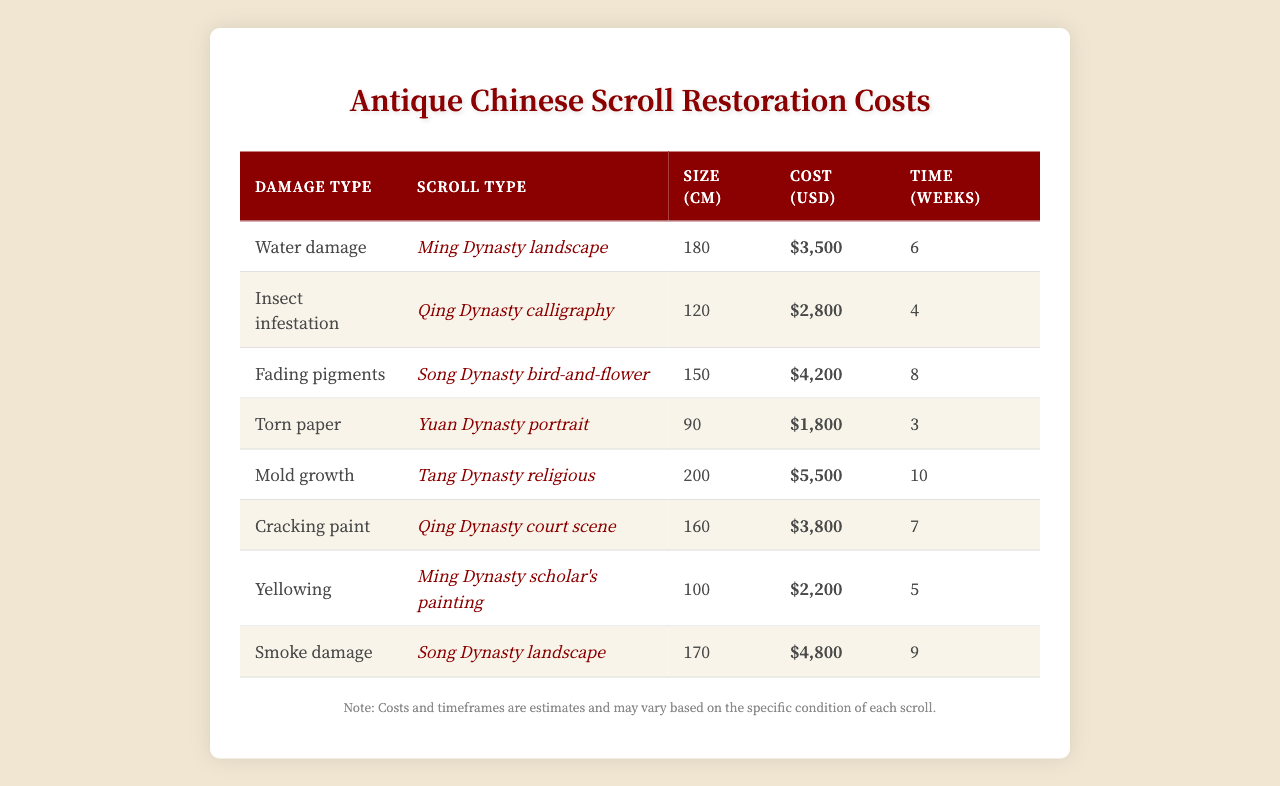What is the restoration cost for a "Ming Dynasty landscape" with water damage? The table indicates that the restoration cost for the "Ming Dynasty landscape" affected by water damage is $3,500.
Answer: $3,500 Which type of damage requires the longest restoration time? By examining the table, the type of damage that takes the longest, at 10 weeks, is mold growth associated with the "Tang Dynasty religious" scroll.
Answer: Mold growth What is the average restoration cost of the scrolls listed in the table? To find the average, first sum the costs: $3,500 + $2,800 + $4,200 + $1,800 + $5,500 + $3,800 + $2,200 + $4,800 = $24,600. Then, divide by the number of scrolls (8): $24,600 / 8 = $3,075.
Answer: $3,075 Which scroll type associated with fading pigments is the most costly to restore? The scroll type with fading pigments is the "Song Dynasty bird-and-flower," which has a restoration cost of $4,200, making it the most costly among that damage type.
Answer: Song Dynasty bird-and-flower Is there any scroll that can be restored for less than $2,000? Reviewing the table, the minimum restoration cost listed is $1,800 for the "Yuan Dynasty portrait" with torn paper, indicating that some scrolls can indeed be restored for less than $2,000.
Answer: Yes How much more expensive is restoring "Smoke damage" compared to "Insect infestation"? The restoration cost for "Smoke damage" is $4,800 and for "Insect infestation" it is $2,800. The difference is $4,800 - $2,800 = $2,000 more expensive.
Answer: $2,000 What is the total time required for restoring scrolls affected by torn paper and yellowing? The scroll affected by torn paper requires 3 weeks, and the scroll with yellowing requires 5 weeks. Summing these gives 3 + 5 = 8 weeks total.
Answer: 8 weeks Which scroll type has the highest restoration cost? From the table, the scroll type with the highest restoration cost is the "Tang Dynasty religious" with mold growth, costing $5,500.
Answer: Tang Dynasty religious What is the median restoration cost from the given data? To find the median, first arrange the costs in order: $1,800, $2,200, $2,800, $3,500, $3,800, $4,200, $4,800, $5,500. The median, being the average of the 4th and 5th values ($3,500 and $3,800), is ($3,500 + $3,800) / 2 = $3,650.
Answer: $3,650 Are there any scroll types that take 6 weeks or less to restore? Inspecting the table for restoration times, both "Torn paper" (3 weeks) and "Insect infestation" (4 weeks) are 6 weeks or less.
Answer: Yes 